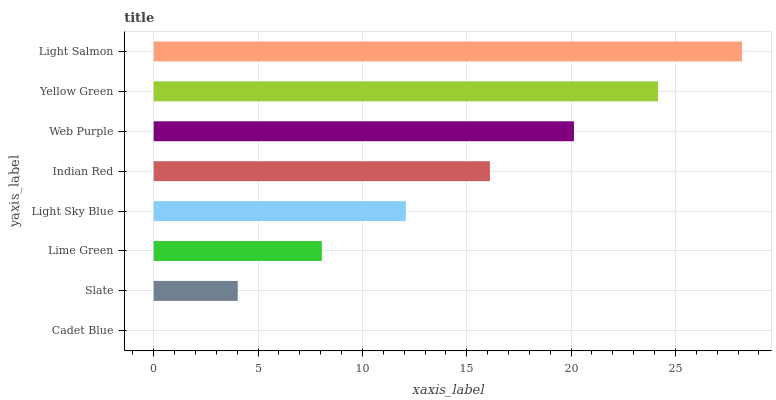Is Cadet Blue the minimum?
Answer yes or no. Yes. Is Light Salmon the maximum?
Answer yes or no. Yes. Is Slate the minimum?
Answer yes or no. No. Is Slate the maximum?
Answer yes or no. No. Is Slate greater than Cadet Blue?
Answer yes or no. Yes. Is Cadet Blue less than Slate?
Answer yes or no. Yes. Is Cadet Blue greater than Slate?
Answer yes or no. No. Is Slate less than Cadet Blue?
Answer yes or no. No. Is Indian Red the high median?
Answer yes or no. Yes. Is Light Sky Blue the low median?
Answer yes or no. Yes. Is Web Purple the high median?
Answer yes or no. No. Is Cadet Blue the low median?
Answer yes or no. No. 